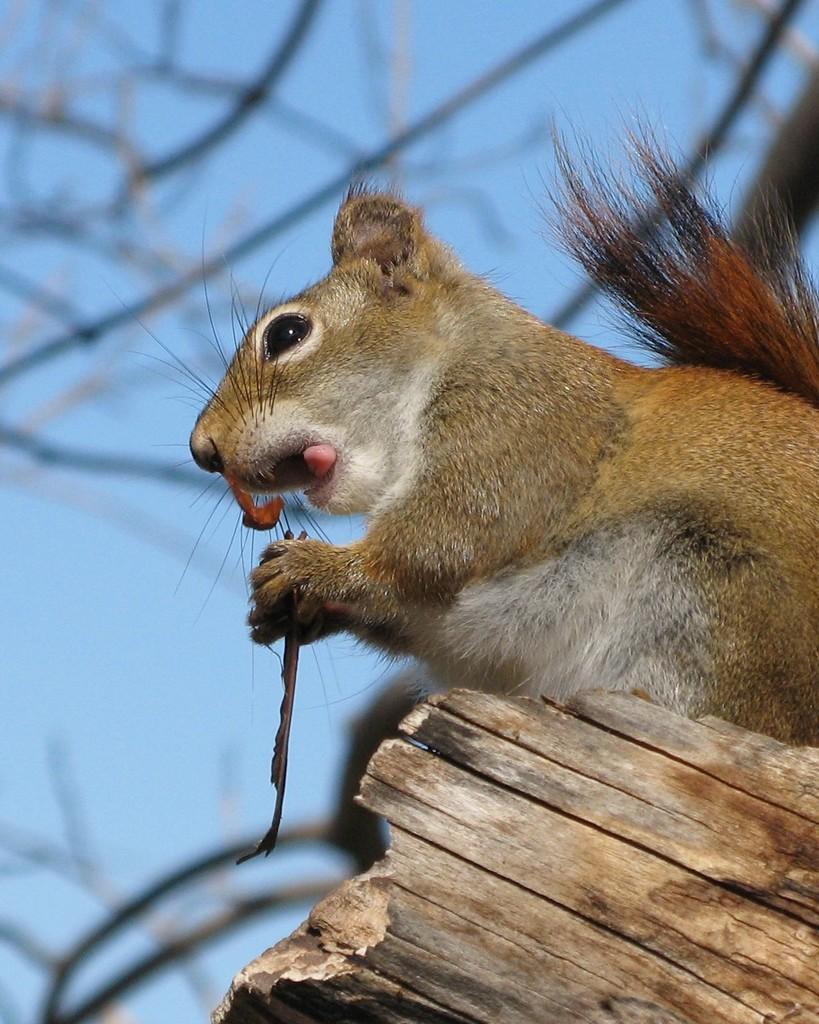How would you summarize this image in a sentence or two? In this image, we can see a squirrel is holding some object. At the bottom, we can see a wooden stick. Background we can see a blur view. Here we can see stems and sky. 